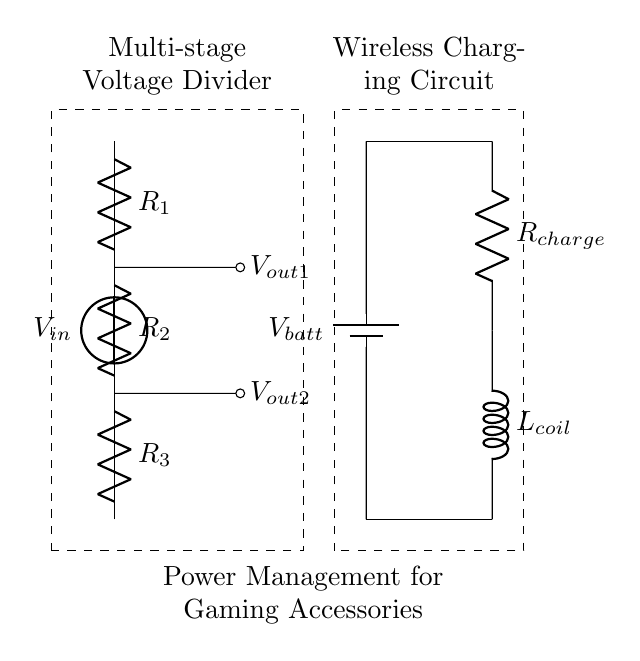What is the input voltage of the circuit? The circuit shows a voltage source labeled \( V_{in} \) at the top, indicating the input voltage is connected from this point.
Answer: \( V_{in} \) What is the total resistance of the voltage divider? The total resistance of a voltage divider can be calculated by adding the resistances of all resistors in series. Here, \( R_1, R_2, \) and \( R_3 \) are connected in series, so \( R_{total} = R_1 + R_2 + R_3 \).
Answer: \( R_1 + R_2 + R_3 \) What are the output voltage points labeled in the circuit? The circuit diagram indicates two output voltages labeled \( V_{out1} \) and \( V_{out2} \). These points are connected across resistors \( R_1 \) and \( R_2 \) respectively.
Answer: \( V_{out1}, V_{out2} \) How does the voltage divider affect the voltage levels for gaming accessories? The voltage divider reduces the input voltage proportionally across the resistors, thereby providing specific, lower voltage levels at each output suitable for powering gaming accessories with varying voltage needs.
Answer: Proportional reduction What role does the inductor named \( L_{coil} \) play in the wireless charging circuit? In wireless charging circuits, the inductor \( L_{coil} \) is used to form a resonant circuit that helps transfer energy wirelessly via electromagnetic induction, facilitating efficient energy transfer from the charger to the gaming accessory.
Answer: Energy transfer 